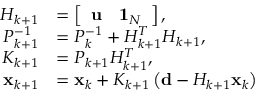<formula> <loc_0><loc_0><loc_500><loc_500>\begin{array} { r l } { H _ { k + 1 } } & { = \left [ \begin{array} { l l } { u } & { { 1 } _ { N } } \end{array} \right ] , } \\ { P _ { k + 1 } ^ { - 1 } } & { = P _ { k } ^ { - 1 } + H _ { k + 1 } ^ { T } H _ { k + 1 } , } \\ { K _ { k + 1 } } & { = P _ { k + 1 } H _ { k + 1 } ^ { T } , } \\ { { x } _ { k + 1 } } & { = { x } _ { k } + K _ { k + 1 } \left ( { d } - H _ { k + 1 } { x } _ { k } \right ) } \end{array}</formula> 